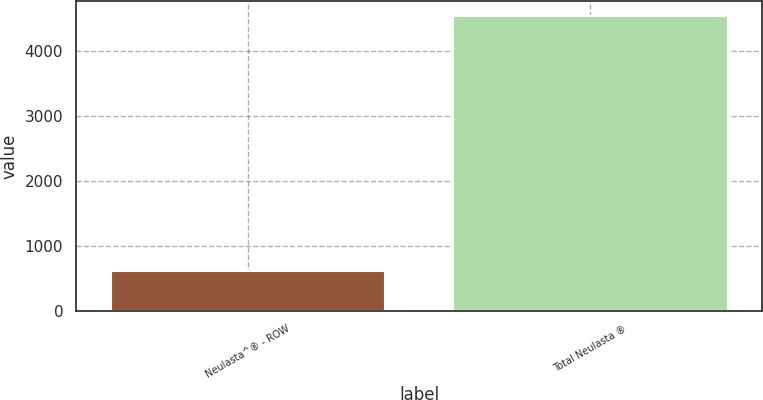Convert chart. <chart><loc_0><loc_0><loc_500><loc_500><bar_chart><fcel>Neulasta^® - ROW<fcel>Total Neulasta ®<nl><fcel>603<fcel>4534<nl></chart> 